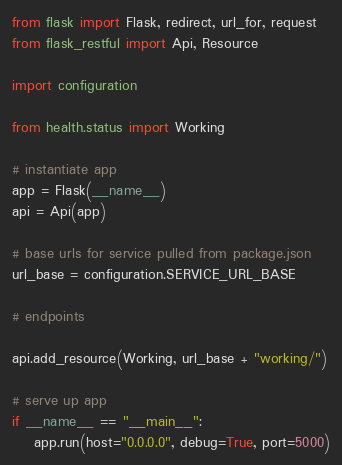<code> <loc_0><loc_0><loc_500><loc_500><_Python_>from flask import Flask, redirect, url_for, request
from flask_restful import Api, Resource

import configuration

from health.status import Working

# instantiate app
app = Flask(__name__)
api = Api(app)

# base urls for service pulled from package.json
url_base = configuration.SERVICE_URL_BASE

# endpoints

api.add_resource(Working, url_base + "working/")

# serve up app
if __name__ == "__main__":
    app.run(host="0.0.0.0", debug=True, port=5000)</code> 